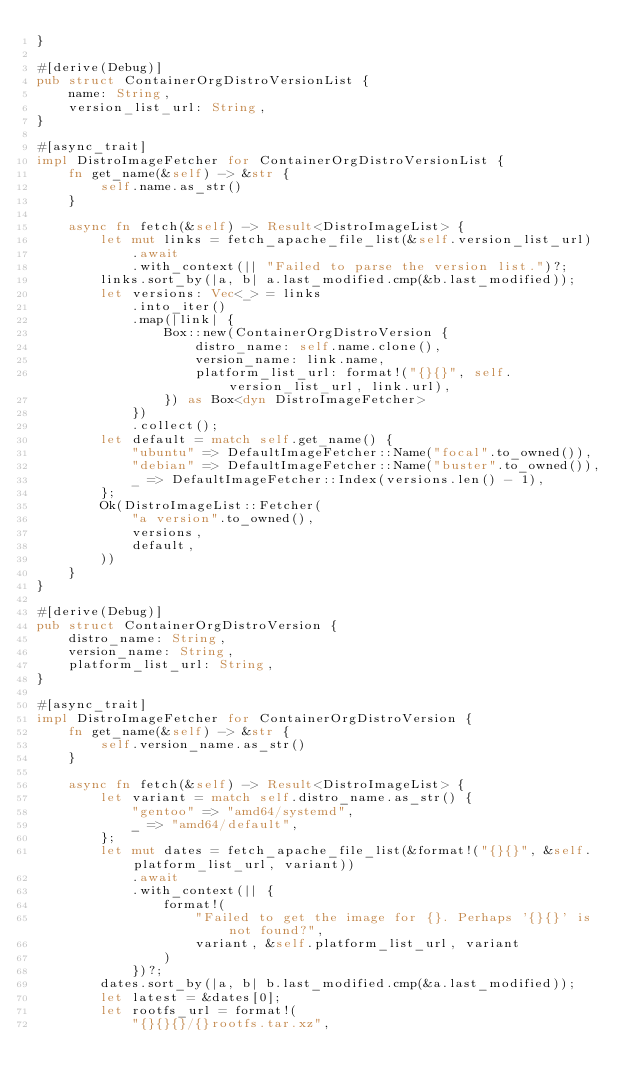Convert code to text. <code><loc_0><loc_0><loc_500><loc_500><_Rust_>}

#[derive(Debug)]
pub struct ContainerOrgDistroVersionList {
    name: String,
    version_list_url: String,
}

#[async_trait]
impl DistroImageFetcher for ContainerOrgDistroVersionList {
    fn get_name(&self) -> &str {
        self.name.as_str()
    }

    async fn fetch(&self) -> Result<DistroImageList> {
        let mut links = fetch_apache_file_list(&self.version_list_url)
            .await
            .with_context(|| "Failed to parse the version list.")?;
        links.sort_by(|a, b| a.last_modified.cmp(&b.last_modified));
        let versions: Vec<_> = links
            .into_iter()
            .map(|link| {
                Box::new(ContainerOrgDistroVersion {
                    distro_name: self.name.clone(),
                    version_name: link.name,
                    platform_list_url: format!("{}{}", self.version_list_url, link.url),
                }) as Box<dyn DistroImageFetcher>
            })
            .collect();
        let default = match self.get_name() {
            "ubuntu" => DefaultImageFetcher::Name("focal".to_owned()),
            "debian" => DefaultImageFetcher::Name("buster".to_owned()),
            _ => DefaultImageFetcher::Index(versions.len() - 1),
        };
        Ok(DistroImageList::Fetcher(
            "a version".to_owned(),
            versions,
            default,
        ))
    }
}

#[derive(Debug)]
pub struct ContainerOrgDistroVersion {
    distro_name: String,
    version_name: String,
    platform_list_url: String,
}

#[async_trait]
impl DistroImageFetcher for ContainerOrgDistroVersion {
    fn get_name(&self) -> &str {
        self.version_name.as_str()
    }

    async fn fetch(&self) -> Result<DistroImageList> {
        let variant = match self.distro_name.as_str() {
            "gentoo" => "amd64/systemd",
            _ => "amd64/default",
        };
        let mut dates = fetch_apache_file_list(&format!("{}{}", &self.platform_list_url, variant))
            .await
            .with_context(|| {
                format!(
                    "Failed to get the image for {}. Perhaps '{}{}' is not found?",
                    variant, &self.platform_list_url, variant
                )
            })?;
        dates.sort_by(|a, b| b.last_modified.cmp(&a.last_modified));
        let latest = &dates[0];
        let rootfs_url = format!(
            "{}{}{}/{}rootfs.tar.xz",</code> 